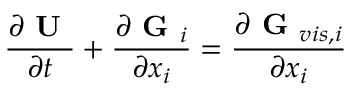Convert formula to latex. <formula><loc_0><loc_0><loc_500><loc_500>\frac { \partial U } { \partial t } + \frac { \partial G _ { i } } { \partial x _ { i } } = \frac { \partial G _ { v i s , i } } { \partial x _ { i } }</formula> 